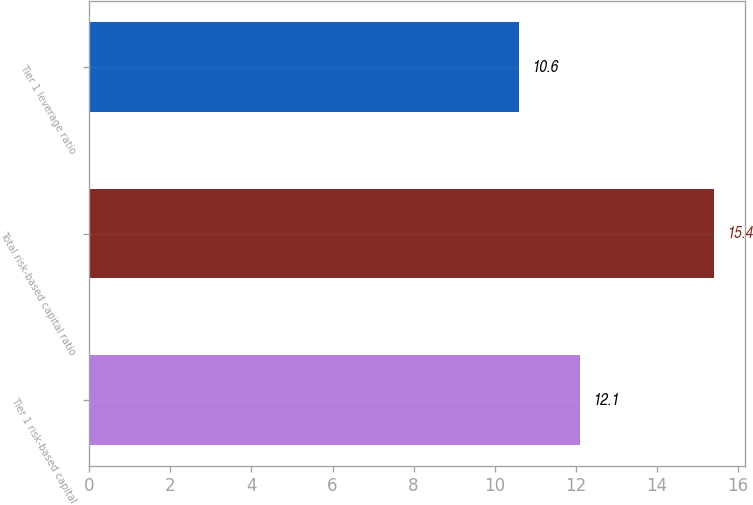Convert chart to OTSL. <chart><loc_0><loc_0><loc_500><loc_500><bar_chart><fcel>Tier 1 risk-based capital<fcel>Total risk-based capital ratio<fcel>Tier 1 leverage ratio<nl><fcel>12.1<fcel>15.4<fcel>10.6<nl></chart> 